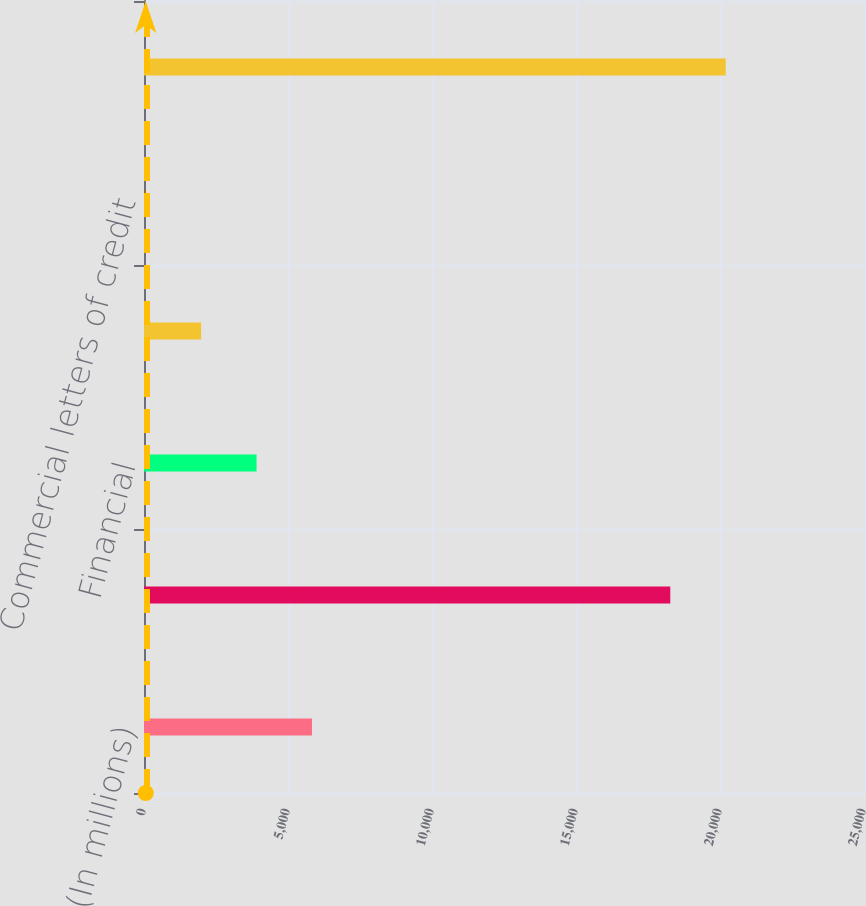Convert chart. <chart><loc_0><loc_0><loc_500><loc_500><bar_chart><fcel>(In millions)<fcel>Net unfunded commitments to<fcel>Financial<fcel>Performance<fcel>Commercial letters of credit<fcel>Total unfunded lending<nl><fcel>5832.3<fcel>18274<fcel>3908.2<fcel>1984.1<fcel>60<fcel>20198.1<nl></chart> 